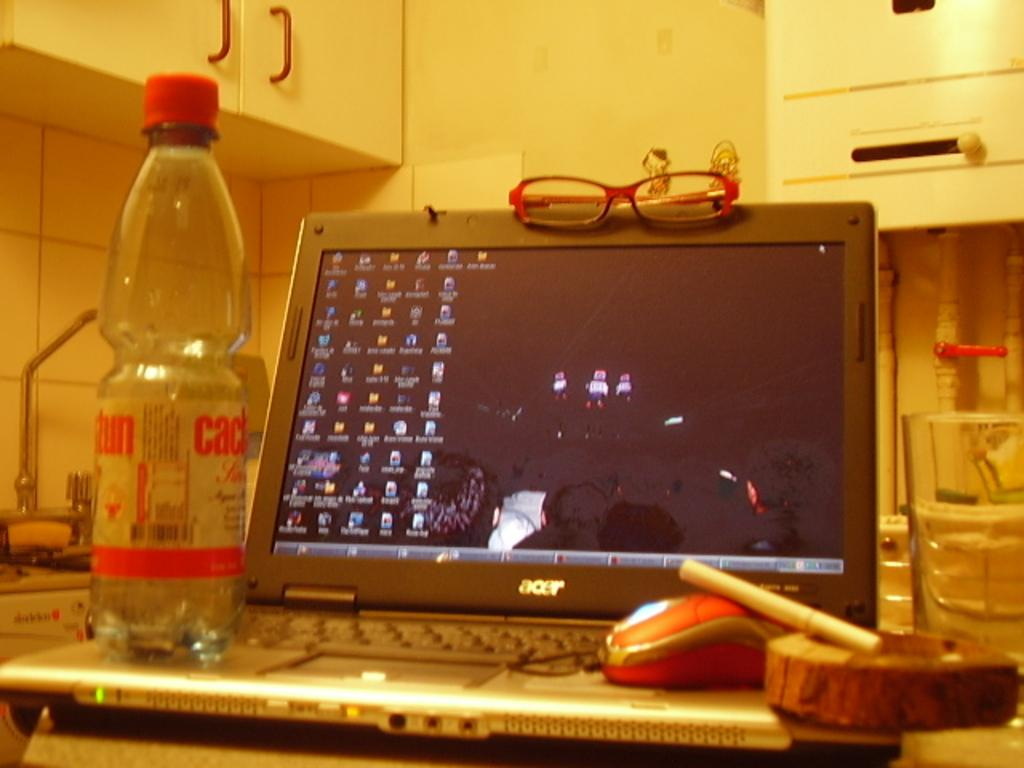What electronic device is visible in the image? There is a laptop in the image. What is used to control the laptop in the image? There is a mouse on the laptop. What is present for smoking in the image? There is an ashtray and a cigarette in the image. What is available for drinking in the image? There is a water bottle in the image. What is used for vision in the image? There are glasses in the image. What type of furniture is visible in the background of the image? There is a wall cupboard in the background of the image. What is used for washing in the background of the image? There is a sink in the background of the image. What is used for plumbing in the background of the image? There are pipes in the background of the image. What type of bird can be seen in the image? There is no bird present in the image. What type of parent is visible in the image? There is no parent present in the image. 